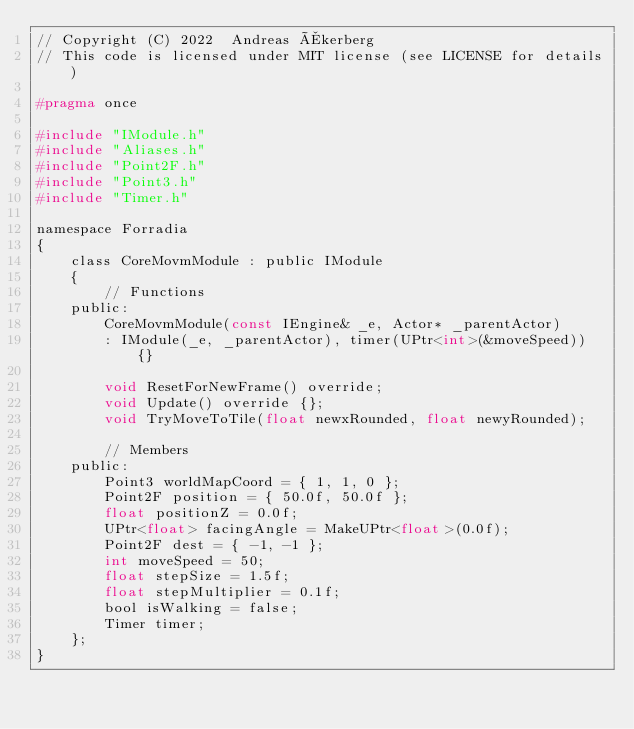<code> <loc_0><loc_0><loc_500><loc_500><_C_>// Copyright (C) 2022  Andreas Åkerberg
// This code is licensed under MIT license (see LICENSE for details)

#pragma once

#include "IModule.h"
#include "Aliases.h"
#include "Point2F.h"
#include "Point3.h"
#include "Timer.h"

namespace Forradia
{
    class CoreMovmModule : public IModule
    {
        // Functions
    public:
        CoreMovmModule(const IEngine& _e, Actor* _parentActor)
		: IModule(_e, _parentActor), timer(UPtr<int>(&moveSpeed)) {}

        void ResetForNewFrame() override;
        void Update() override {};
        void TryMoveToTile(float newxRounded, float newyRounded);

        // Members
    public:
        Point3 worldMapCoord = { 1, 1, 0 };
        Point2F position = { 50.0f, 50.0f };
        float positionZ = 0.0f;
        UPtr<float> facingAngle = MakeUPtr<float>(0.0f);
        Point2F dest = { -1, -1 };
        int moveSpeed = 50;
        float stepSize = 1.5f;
        float stepMultiplier = 0.1f;
        bool isWalking = false;
        Timer timer;
    };
}</code> 